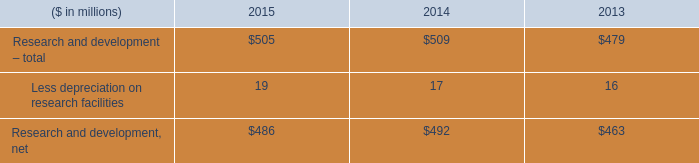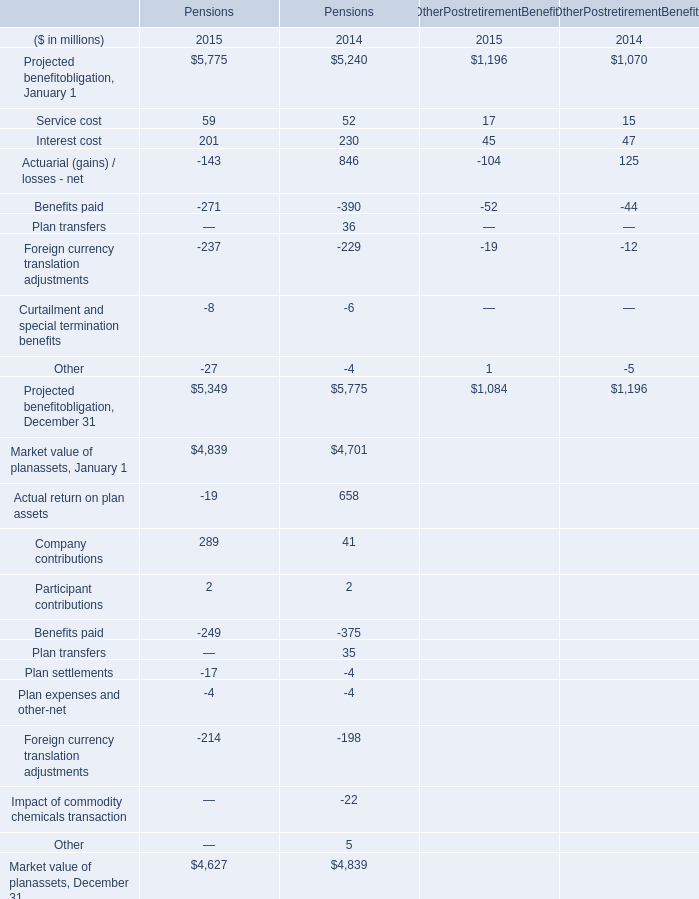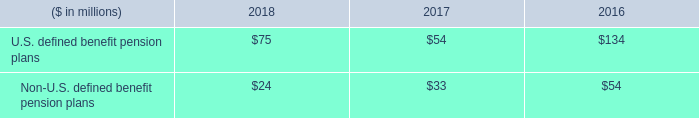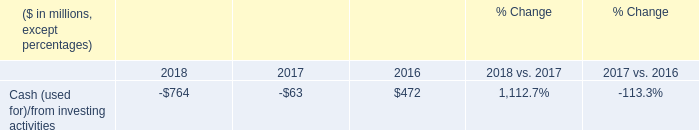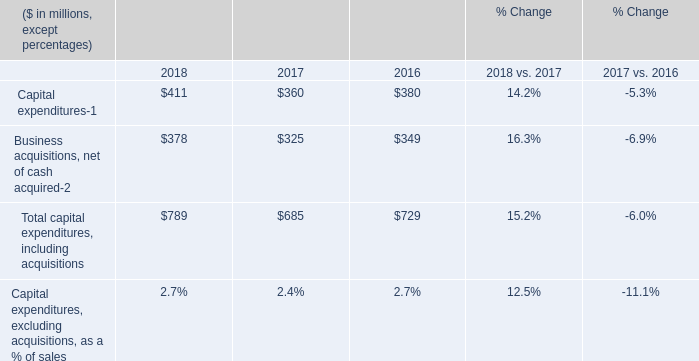In the year with the most Other for Pensions, what is the growth rate of Company contributions for Pensions? 
Computations: ((289 - 41) / 41)
Answer: 6.04878. 